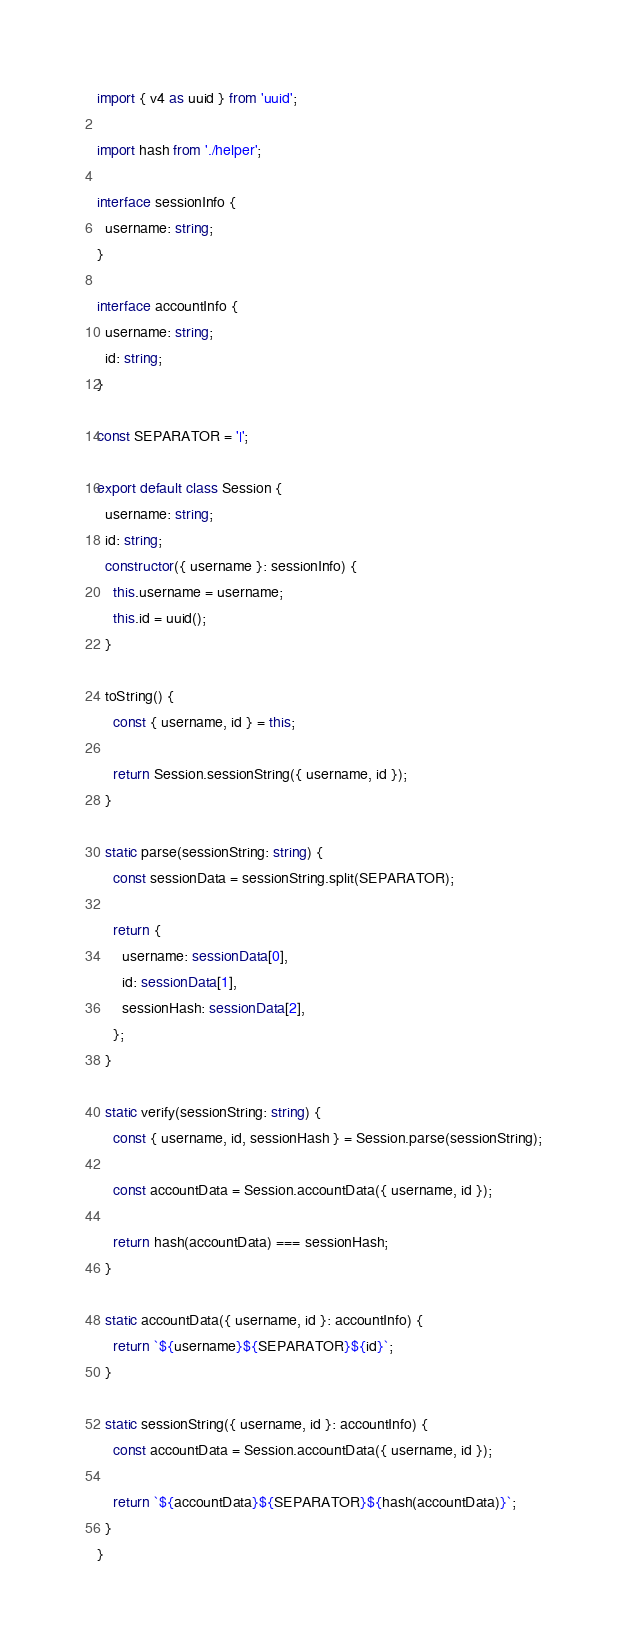<code> <loc_0><loc_0><loc_500><loc_500><_TypeScript_>import { v4 as uuid } from 'uuid';

import hash from './helper';

interface sessionInfo {
  username: string;
}

interface accountInfo {
  username: string;
  id: string;
}

const SEPARATOR = '|';

export default class Session {
  username: string;
  id: string;
  constructor({ username }: sessionInfo) {
    this.username = username;
    this.id = uuid();
  }

  toString() {
    const { username, id } = this;

    return Session.sessionString({ username, id });
  }

  static parse(sessionString: string) {
    const sessionData = sessionString.split(SEPARATOR);

    return {
      username: sessionData[0],
      id: sessionData[1],
      sessionHash: sessionData[2],
    };
  }

  static verify(sessionString: string) {
    const { username, id, sessionHash } = Session.parse(sessionString);

    const accountData = Session.accountData({ username, id });

    return hash(accountData) === sessionHash;
  }

  static accountData({ username, id }: accountInfo) {
    return `${username}${SEPARATOR}${id}`;
  }

  static sessionString({ username, id }: accountInfo) {
    const accountData = Session.accountData({ username, id });

    return `${accountData}${SEPARATOR}${hash(accountData)}`;
  }
}
</code> 